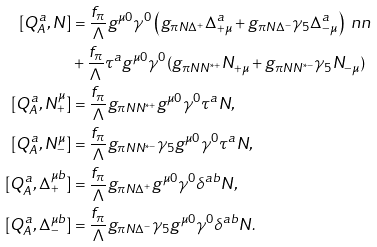Convert formula to latex. <formula><loc_0><loc_0><loc_500><loc_500>[ Q _ { A } ^ { a } , N ] & = \frac { f _ { \pi } } { \Lambda } g ^ { \mu 0 } \gamma ^ { 0 } \left ( g _ { \pi N \Delta ^ { + } } \Delta _ { + \mu } ^ { a } + g _ { \pi N \Delta ^ { - } } \gamma _ { 5 } \Delta _ { - \mu } ^ { a } \right ) \ n n \\ & + \frac { f _ { \pi } } { \Lambda } \tau ^ { a } g ^ { \mu 0 } \gamma ^ { 0 } ( g _ { \pi N N ^ { * + } } N _ { + \mu } + g _ { \pi N N ^ { * - } } \gamma _ { 5 } N _ { - \mu } ) \\ [ Q _ { A } ^ { a } , N _ { + } ^ { \mu } ] & = \frac { f _ { \pi } } { \Lambda } g _ { \pi N N ^ { * + } } g ^ { \mu 0 } \gamma ^ { 0 } \tau ^ { a } N , \\ [ Q _ { A } ^ { a } , N _ { - } ^ { \mu } ] & = \frac { f _ { \pi } } { \Lambda } g _ { \pi N N ^ { * - } } \gamma _ { 5 } g ^ { \mu 0 } \gamma ^ { 0 } \tau ^ { a } N , \\ [ Q _ { A } ^ { a } , \Delta _ { + } ^ { \mu b } ] & = \frac { f _ { \pi } } { \Lambda } g _ { \pi N \Delta ^ { + } } g ^ { \mu 0 } \gamma ^ { 0 } \delta ^ { a b } N , \\ [ Q _ { A } ^ { a } , \Delta _ { - } ^ { \mu b } ] & = \frac { f _ { \pi } } { \Lambda } g _ { \pi N \Delta ^ { - } } \gamma _ { 5 } g ^ { \mu 0 } \gamma ^ { 0 } \delta ^ { a b } N .</formula> 